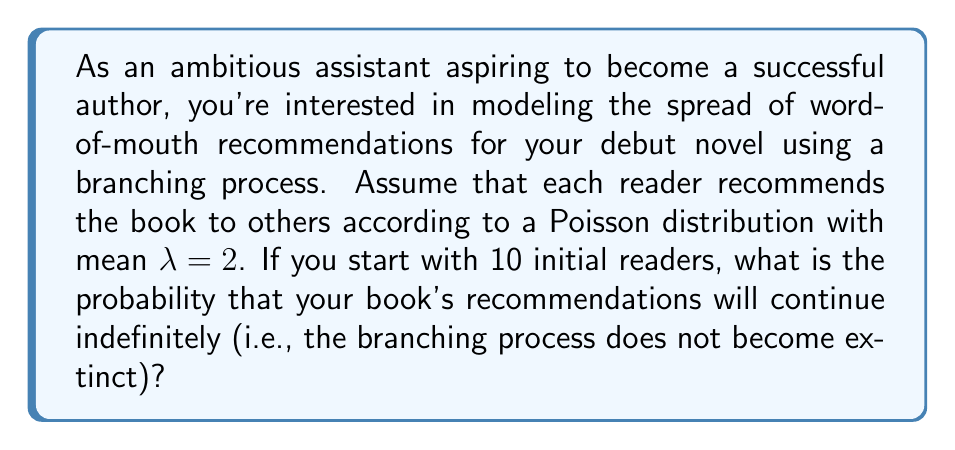Teach me how to tackle this problem. Let's approach this step-by-step:

1) In a branching process, the key factor determining whether the process continues indefinitely or becomes extinct is the mean number of "offspring" per individual, which in this case is $\lambda = 2$.

2) The extinction probability $q$ satisfies the equation:
   $$q = e^{-\lambda(1-q)}$$

3) When $\lambda > 1$, as in this case, there is a unique solution $q < 1$. We can solve this numerically or use the fact that for $\lambda = 2$, $q \approx 0.2032$.

4) The probability of extinction starting with one individual is $q$. With 10 independent starting individuals, the probability of overall extinction is $q^{10}$.

5) Therefore, the probability that the process continues indefinitely (does not become extinct) is:
   $$1 - q^{10} = 1 - (0.2032)^{10} \approx 0.9999999968$$
Answer: $0.9999999968$ 